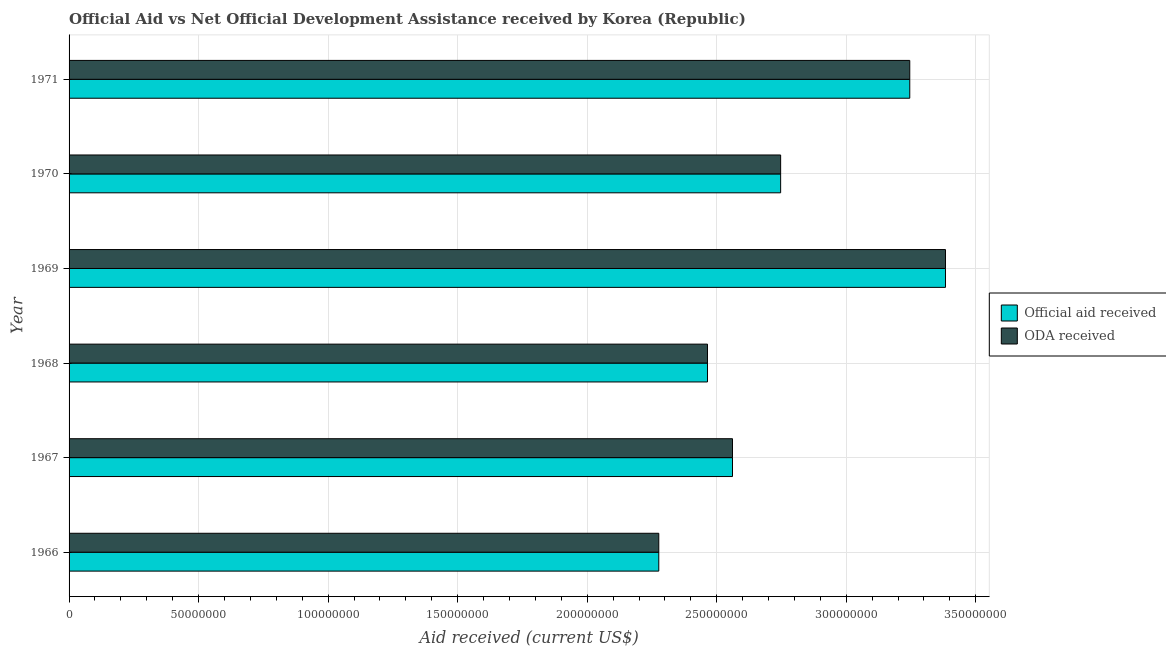How many different coloured bars are there?
Offer a terse response. 2. How many bars are there on the 2nd tick from the top?
Give a very brief answer. 2. How many bars are there on the 1st tick from the bottom?
Your response must be concise. 2. What is the label of the 6th group of bars from the top?
Offer a terse response. 1966. What is the oda received in 1970?
Ensure brevity in your answer.  2.75e+08. Across all years, what is the maximum official aid received?
Your answer should be very brief. 3.38e+08. Across all years, what is the minimum oda received?
Provide a succinct answer. 2.28e+08. In which year was the official aid received maximum?
Ensure brevity in your answer.  1969. In which year was the oda received minimum?
Your answer should be very brief. 1966. What is the total official aid received in the graph?
Offer a terse response. 1.67e+09. What is the difference between the official aid received in 1969 and that in 1971?
Make the answer very short. 1.38e+07. What is the difference between the official aid received in 1968 and the oda received in 1969?
Give a very brief answer. -9.19e+07. What is the average oda received per year?
Provide a short and direct response. 2.78e+08. In the year 1969, what is the difference between the official aid received and oda received?
Offer a very short reply. 0. In how many years, is the official aid received greater than 260000000 US$?
Ensure brevity in your answer.  3. What is the ratio of the oda received in 1969 to that in 1970?
Keep it short and to the point. 1.23. Is the difference between the official aid received in 1966 and 1969 greater than the difference between the oda received in 1966 and 1969?
Make the answer very short. No. What is the difference between the highest and the second highest oda received?
Provide a succinct answer. 1.38e+07. What is the difference between the highest and the lowest oda received?
Your answer should be compact. 1.11e+08. Is the sum of the official aid received in 1968 and 1971 greater than the maximum oda received across all years?
Give a very brief answer. Yes. What does the 2nd bar from the top in 1970 represents?
Offer a terse response. Official aid received. What does the 2nd bar from the bottom in 1966 represents?
Make the answer very short. ODA received. How many bars are there?
Make the answer very short. 12. Are all the bars in the graph horizontal?
Provide a short and direct response. Yes. What is the difference between two consecutive major ticks on the X-axis?
Keep it short and to the point. 5.00e+07. Are the values on the major ticks of X-axis written in scientific E-notation?
Your response must be concise. No. Does the graph contain any zero values?
Your response must be concise. No. How many legend labels are there?
Offer a very short reply. 2. How are the legend labels stacked?
Make the answer very short. Vertical. What is the title of the graph?
Ensure brevity in your answer.  Official Aid vs Net Official Development Assistance received by Korea (Republic) . What is the label or title of the X-axis?
Offer a terse response. Aid received (current US$). What is the label or title of the Y-axis?
Provide a short and direct response. Year. What is the Aid received (current US$) in Official aid received in 1966?
Your response must be concise. 2.28e+08. What is the Aid received (current US$) of ODA received in 1966?
Give a very brief answer. 2.28e+08. What is the Aid received (current US$) of Official aid received in 1967?
Your response must be concise. 2.56e+08. What is the Aid received (current US$) of ODA received in 1967?
Give a very brief answer. 2.56e+08. What is the Aid received (current US$) of Official aid received in 1968?
Offer a terse response. 2.46e+08. What is the Aid received (current US$) of ODA received in 1968?
Ensure brevity in your answer.  2.46e+08. What is the Aid received (current US$) in Official aid received in 1969?
Provide a succinct answer. 3.38e+08. What is the Aid received (current US$) of ODA received in 1969?
Provide a short and direct response. 3.38e+08. What is the Aid received (current US$) in Official aid received in 1970?
Make the answer very short. 2.75e+08. What is the Aid received (current US$) of ODA received in 1970?
Provide a succinct answer. 2.75e+08. What is the Aid received (current US$) in Official aid received in 1971?
Make the answer very short. 3.25e+08. What is the Aid received (current US$) of ODA received in 1971?
Provide a short and direct response. 3.25e+08. Across all years, what is the maximum Aid received (current US$) in Official aid received?
Ensure brevity in your answer.  3.38e+08. Across all years, what is the maximum Aid received (current US$) of ODA received?
Ensure brevity in your answer.  3.38e+08. Across all years, what is the minimum Aid received (current US$) of Official aid received?
Your response must be concise. 2.28e+08. Across all years, what is the minimum Aid received (current US$) of ODA received?
Provide a short and direct response. 2.28e+08. What is the total Aid received (current US$) of Official aid received in the graph?
Provide a succinct answer. 1.67e+09. What is the total Aid received (current US$) of ODA received in the graph?
Provide a succinct answer. 1.67e+09. What is the difference between the Aid received (current US$) in Official aid received in 1966 and that in 1967?
Provide a short and direct response. -2.85e+07. What is the difference between the Aid received (current US$) in ODA received in 1966 and that in 1967?
Ensure brevity in your answer.  -2.85e+07. What is the difference between the Aid received (current US$) in Official aid received in 1966 and that in 1968?
Provide a short and direct response. -1.88e+07. What is the difference between the Aid received (current US$) of ODA received in 1966 and that in 1968?
Offer a very short reply. -1.88e+07. What is the difference between the Aid received (current US$) in Official aid received in 1966 and that in 1969?
Provide a short and direct response. -1.11e+08. What is the difference between the Aid received (current US$) in ODA received in 1966 and that in 1969?
Your answer should be very brief. -1.11e+08. What is the difference between the Aid received (current US$) of Official aid received in 1966 and that in 1970?
Keep it short and to the point. -4.70e+07. What is the difference between the Aid received (current US$) of ODA received in 1966 and that in 1970?
Your response must be concise. -4.70e+07. What is the difference between the Aid received (current US$) in Official aid received in 1966 and that in 1971?
Keep it short and to the point. -9.69e+07. What is the difference between the Aid received (current US$) in ODA received in 1966 and that in 1971?
Give a very brief answer. -9.69e+07. What is the difference between the Aid received (current US$) of Official aid received in 1967 and that in 1968?
Make the answer very short. 9.66e+06. What is the difference between the Aid received (current US$) of ODA received in 1967 and that in 1968?
Provide a short and direct response. 9.66e+06. What is the difference between the Aid received (current US$) of Official aid received in 1967 and that in 1969?
Give a very brief answer. -8.22e+07. What is the difference between the Aid received (current US$) of ODA received in 1967 and that in 1969?
Offer a terse response. -8.22e+07. What is the difference between the Aid received (current US$) of Official aid received in 1967 and that in 1970?
Your response must be concise. -1.86e+07. What is the difference between the Aid received (current US$) of ODA received in 1967 and that in 1970?
Make the answer very short. -1.86e+07. What is the difference between the Aid received (current US$) of Official aid received in 1967 and that in 1971?
Your response must be concise. -6.84e+07. What is the difference between the Aid received (current US$) of ODA received in 1967 and that in 1971?
Give a very brief answer. -6.84e+07. What is the difference between the Aid received (current US$) of Official aid received in 1968 and that in 1969?
Provide a short and direct response. -9.19e+07. What is the difference between the Aid received (current US$) of ODA received in 1968 and that in 1969?
Your answer should be compact. -9.19e+07. What is the difference between the Aid received (current US$) of Official aid received in 1968 and that in 1970?
Ensure brevity in your answer.  -2.82e+07. What is the difference between the Aid received (current US$) in ODA received in 1968 and that in 1970?
Make the answer very short. -2.82e+07. What is the difference between the Aid received (current US$) in Official aid received in 1968 and that in 1971?
Offer a terse response. -7.81e+07. What is the difference between the Aid received (current US$) in ODA received in 1968 and that in 1971?
Your answer should be compact. -7.81e+07. What is the difference between the Aid received (current US$) in Official aid received in 1969 and that in 1970?
Give a very brief answer. 6.36e+07. What is the difference between the Aid received (current US$) of ODA received in 1969 and that in 1970?
Ensure brevity in your answer.  6.36e+07. What is the difference between the Aid received (current US$) in Official aid received in 1969 and that in 1971?
Provide a succinct answer. 1.38e+07. What is the difference between the Aid received (current US$) in ODA received in 1969 and that in 1971?
Offer a terse response. 1.38e+07. What is the difference between the Aid received (current US$) in Official aid received in 1970 and that in 1971?
Provide a succinct answer. -4.98e+07. What is the difference between the Aid received (current US$) of ODA received in 1970 and that in 1971?
Offer a terse response. -4.98e+07. What is the difference between the Aid received (current US$) of Official aid received in 1966 and the Aid received (current US$) of ODA received in 1967?
Ensure brevity in your answer.  -2.85e+07. What is the difference between the Aid received (current US$) in Official aid received in 1966 and the Aid received (current US$) in ODA received in 1968?
Provide a short and direct response. -1.88e+07. What is the difference between the Aid received (current US$) in Official aid received in 1966 and the Aid received (current US$) in ODA received in 1969?
Offer a very short reply. -1.11e+08. What is the difference between the Aid received (current US$) in Official aid received in 1966 and the Aid received (current US$) in ODA received in 1970?
Your answer should be very brief. -4.70e+07. What is the difference between the Aid received (current US$) in Official aid received in 1966 and the Aid received (current US$) in ODA received in 1971?
Provide a short and direct response. -9.69e+07. What is the difference between the Aid received (current US$) in Official aid received in 1967 and the Aid received (current US$) in ODA received in 1968?
Keep it short and to the point. 9.66e+06. What is the difference between the Aid received (current US$) in Official aid received in 1967 and the Aid received (current US$) in ODA received in 1969?
Your answer should be compact. -8.22e+07. What is the difference between the Aid received (current US$) of Official aid received in 1967 and the Aid received (current US$) of ODA received in 1970?
Your answer should be compact. -1.86e+07. What is the difference between the Aid received (current US$) of Official aid received in 1967 and the Aid received (current US$) of ODA received in 1971?
Your answer should be compact. -6.84e+07. What is the difference between the Aid received (current US$) of Official aid received in 1968 and the Aid received (current US$) of ODA received in 1969?
Provide a short and direct response. -9.19e+07. What is the difference between the Aid received (current US$) in Official aid received in 1968 and the Aid received (current US$) in ODA received in 1970?
Your response must be concise. -2.82e+07. What is the difference between the Aid received (current US$) of Official aid received in 1968 and the Aid received (current US$) of ODA received in 1971?
Keep it short and to the point. -7.81e+07. What is the difference between the Aid received (current US$) of Official aid received in 1969 and the Aid received (current US$) of ODA received in 1970?
Give a very brief answer. 6.36e+07. What is the difference between the Aid received (current US$) of Official aid received in 1969 and the Aid received (current US$) of ODA received in 1971?
Offer a very short reply. 1.38e+07. What is the difference between the Aid received (current US$) of Official aid received in 1970 and the Aid received (current US$) of ODA received in 1971?
Ensure brevity in your answer.  -4.98e+07. What is the average Aid received (current US$) of Official aid received per year?
Offer a very short reply. 2.78e+08. What is the average Aid received (current US$) in ODA received per year?
Offer a terse response. 2.78e+08. In the year 1967, what is the difference between the Aid received (current US$) of Official aid received and Aid received (current US$) of ODA received?
Your response must be concise. 0. In the year 1968, what is the difference between the Aid received (current US$) in Official aid received and Aid received (current US$) in ODA received?
Ensure brevity in your answer.  0. What is the ratio of the Aid received (current US$) in ODA received in 1966 to that in 1967?
Offer a very short reply. 0.89. What is the ratio of the Aid received (current US$) in Official aid received in 1966 to that in 1968?
Your response must be concise. 0.92. What is the ratio of the Aid received (current US$) in ODA received in 1966 to that in 1968?
Offer a terse response. 0.92. What is the ratio of the Aid received (current US$) of Official aid received in 1966 to that in 1969?
Your response must be concise. 0.67. What is the ratio of the Aid received (current US$) in ODA received in 1966 to that in 1969?
Offer a terse response. 0.67. What is the ratio of the Aid received (current US$) of Official aid received in 1966 to that in 1970?
Make the answer very short. 0.83. What is the ratio of the Aid received (current US$) in ODA received in 1966 to that in 1970?
Make the answer very short. 0.83. What is the ratio of the Aid received (current US$) of Official aid received in 1966 to that in 1971?
Your response must be concise. 0.7. What is the ratio of the Aid received (current US$) of ODA received in 1966 to that in 1971?
Ensure brevity in your answer.  0.7. What is the ratio of the Aid received (current US$) of Official aid received in 1967 to that in 1968?
Your answer should be very brief. 1.04. What is the ratio of the Aid received (current US$) of ODA received in 1967 to that in 1968?
Provide a succinct answer. 1.04. What is the ratio of the Aid received (current US$) of Official aid received in 1967 to that in 1969?
Your answer should be very brief. 0.76. What is the ratio of the Aid received (current US$) in ODA received in 1967 to that in 1969?
Ensure brevity in your answer.  0.76. What is the ratio of the Aid received (current US$) in Official aid received in 1967 to that in 1970?
Offer a terse response. 0.93. What is the ratio of the Aid received (current US$) in ODA received in 1967 to that in 1970?
Ensure brevity in your answer.  0.93. What is the ratio of the Aid received (current US$) in Official aid received in 1967 to that in 1971?
Your answer should be very brief. 0.79. What is the ratio of the Aid received (current US$) in ODA received in 1967 to that in 1971?
Give a very brief answer. 0.79. What is the ratio of the Aid received (current US$) in Official aid received in 1968 to that in 1969?
Provide a short and direct response. 0.73. What is the ratio of the Aid received (current US$) in ODA received in 1968 to that in 1969?
Your response must be concise. 0.73. What is the ratio of the Aid received (current US$) of Official aid received in 1968 to that in 1970?
Make the answer very short. 0.9. What is the ratio of the Aid received (current US$) in ODA received in 1968 to that in 1970?
Offer a very short reply. 0.9. What is the ratio of the Aid received (current US$) in Official aid received in 1968 to that in 1971?
Make the answer very short. 0.76. What is the ratio of the Aid received (current US$) of ODA received in 1968 to that in 1971?
Offer a terse response. 0.76. What is the ratio of the Aid received (current US$) of Official aid received in 1969 to that in 1970?
Your response must be concise. 1.23. What is the ratio of the Aid received (current US$) of ODA received in 1969 to that in 1970?
Your answer should be compact. 1.23. What is the ratio of the Aid received (current US$) in Official aid received in 1969 to that in 1971?
Ensure brevity in your answer.  1.04. What is the ratio of the Aid received (current US$) of ODA received in 1969 to that in 1971?
Ensure brevity in your answer.  1.04. What is the ratio of the Aid received (current US$) in Official aid received in 1970 to that in 1971?
Keep it short and to the point. 0.85. What is the ratio of the Aid received (current US$) of ODA received in 1970 to that in 1971?
Provide a short and direct response. 0.85. What is the difference between the highest and the second highest Aid received (current US$) in Official aid received?
Ensure brevity in your answer.  1.38e+07. What is the difference between the highest and the second highest Aid received (current US$) of ODA received?
Your answer should be very brief. 1.38e+07. What is the difference between the highest and the lowest Aid received (current US$) of Official aid received?
Make the answer very short. 1.11e+08. What is the difference between the highest and the lowest Aid received (current US$) of ODA received?
Provide a short and direct response. 1.11e+08. 